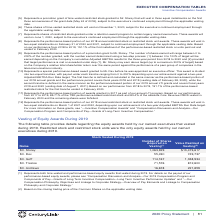According to Centurylink's financial document, What is the value realized on vesting based on? the closing trading price of the Common Shares on the applicable vesting date. The document states: "(2) Based on the closing trading price of the Common Shares on the applicable vesting date...." Also, What were the equity awards held by named executives during 2019? Restricted stock and restricted stock units. The document states: "by our named executives that vested during 2019. Restricted stock and restricted stock units were the only equity awards held by our named executives ..." Also, What does the number of shares acquired on vesting represent? both time-vested and performance-based equity awards that vested during 2019.. The document states: "(1) Represents both time-vested and performance-based equity awards that vested during 2019. For details on the payout of our performance-based equity..." Also, How many named executives who hold equity awards and vested during 2019 are there? Counting the relevant items in the document: Mr. Storey, Mr. Dev, Mr. Goff, Mr. Trezise, Mr. Andrews, I find 5 instances. The key data points involved are: Mr. Andrews, Mr. Dev, Mr. Goff. Also, can you calculate: What is the difference in the value realized on vesting between Mr. Trezise and Mr. Dev?  Based on the calculation: $812,600-$749,737, the result is 62863. This is based on the information: "Mr. Dev 55,490 749,737 Mr. Trezise 71,576 812,600..." The key data points involved are: 749,737, 812,600. Also, can you calculate: What is the average number of shares acquired on vesting? To answer this question, I need to perform calculations using the financial data. The calculation is: (1,063,929+55,490+114,167+71,576+16,678)/5, which equals 264368. This is based on the information: "Mr. Andrews 16,678 221,859 Mr. Goff 114,167 1,338,934 Mr. Dev 55,490 749,737 Mr. Storey 1,063,929 $13,479,617 Mr. Trezise 71,576 812,600..." The key data points involved are: 1,063,929, 114,167, 16,678. 